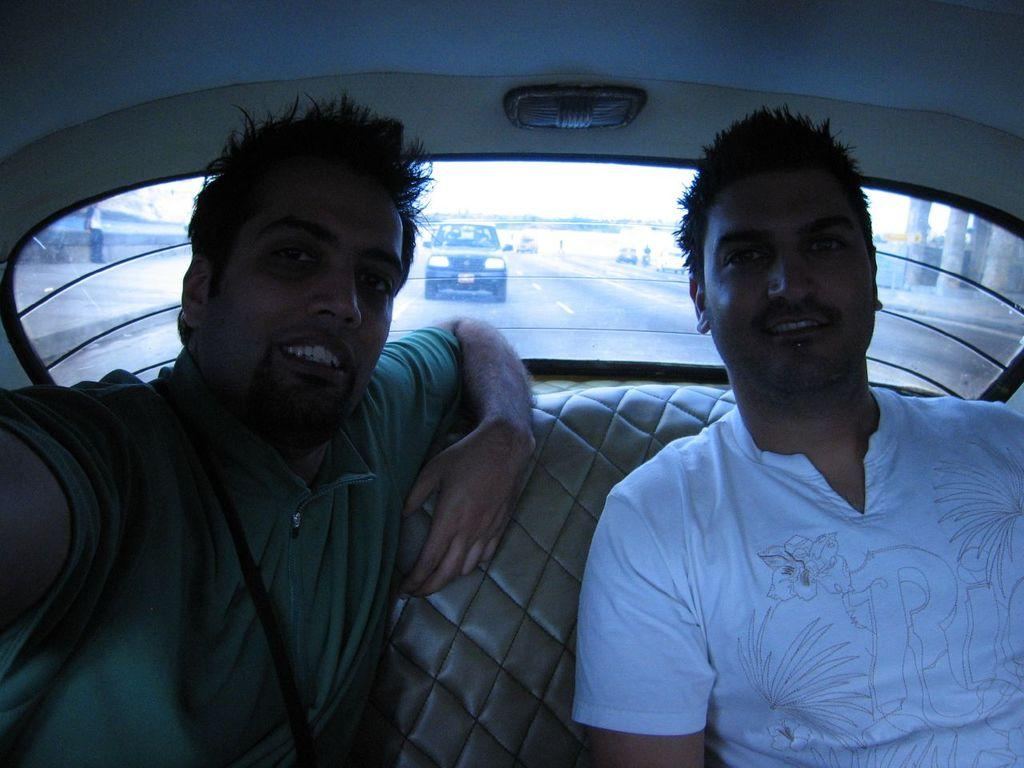How many people are inside the vehicle in the image? There are two men sitting inside the vehicle. What type of window is present in the vehicle? There is a glass window in the vehicle. What can be seen through the window in the image? A car visible on the road and the sky can be seen through the window. What type of furniture is visible in the image? There is no furniture visible in the image; it features two men sitting inside a vehicle. What disease is the man in the passenger seat suffering from in the image? There is no indication of any disease in the image; it only shows two men sitting inside a vehicle. 